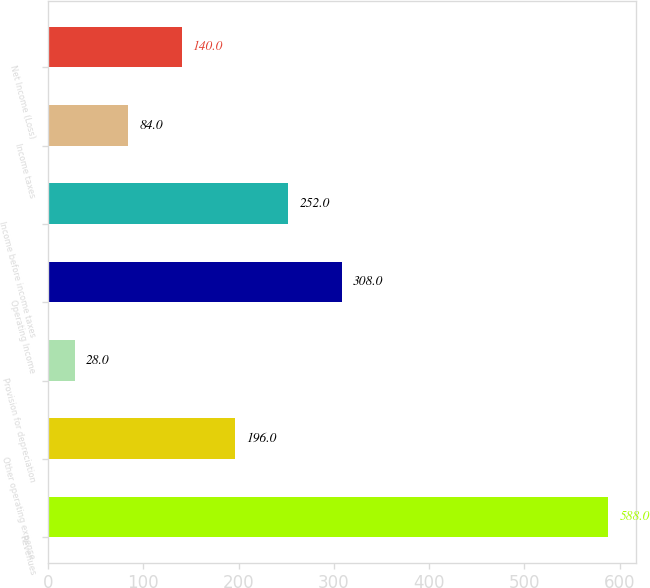Convert chart. <chart><loc_0><loc_0><loc_500><loc_500><bar_chart><fcel>Revenues<fcel>Other operating expense<fcel>Provision for depreciation<fcel>Operating Income<fcel>Income before income taxes<fcel>Income taxes<fcel>Net Income (Loss)<nl><fcel>588<fcel>196<fcel>28<fcel>308<fcel>252<fcel>84<fcel>140<nl></chart> 